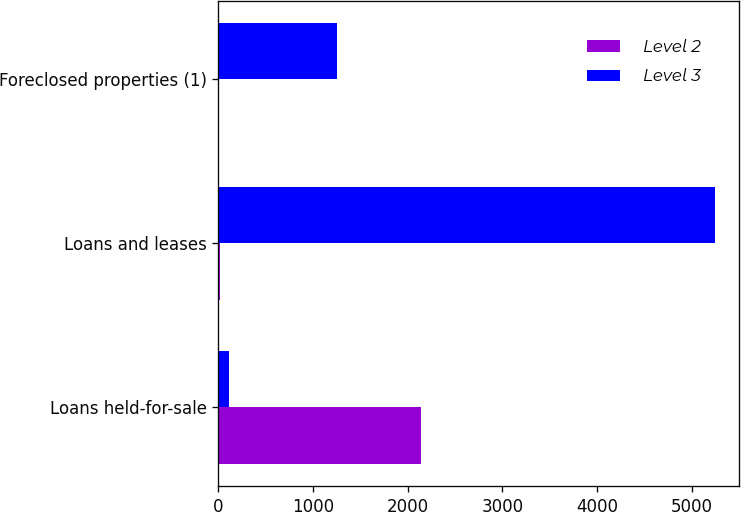Convert chart to OTSL. <chart><loc_0><loc_0><loc_500><loc_500><stacked_bar_chart><ecel><fcel>Loans held-for-sale<fcel>Loans and leases<fcel>Foreclosed properties (1)<nl><fcel>Level 2<fcel>2138<fcel>18<fcel>12<nl><fcel>Level 3<fcel>115<fcel>5240<fcel>1258<nl></chart> 